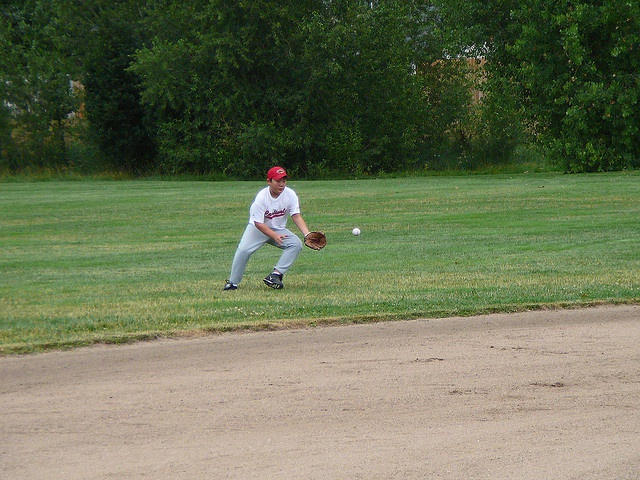Describe the objects in this image and their specific colors. I can see people in black, lavender, green, darkgray, and gray tones, baseball glove in black, maroon, and gray tones, and sports ball in black, lightgray, darkgray, and gray tones in this image. 